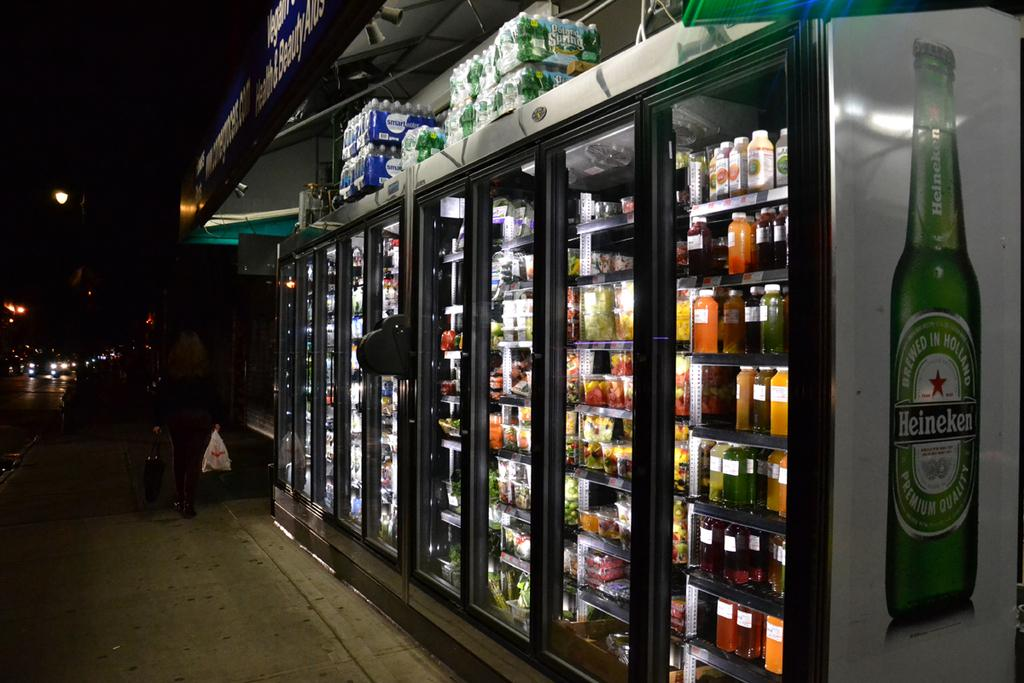<image>
Provide a brief description of the given image. Cold beverage display case on the road selling Heineken beer along with other drinks. 